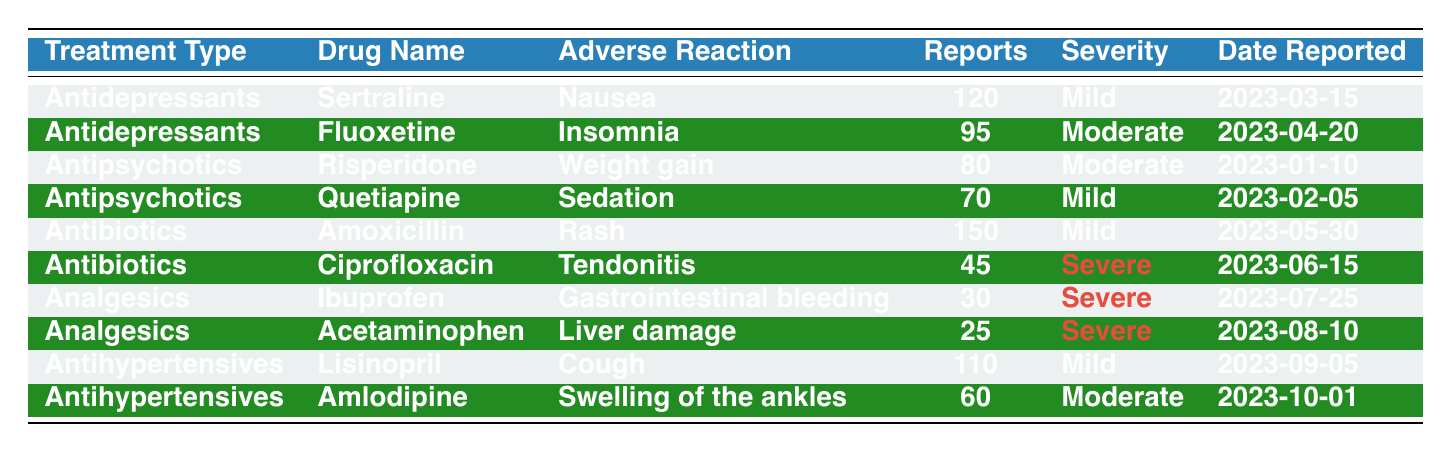What is the drug with the highest number of adverse reaction reports? The table lists the number of reports for each drug. Amoxicillin has the highest number at 150 reports.
Answer: Amoxicillin Which treatment type had the most reports of severe adverse reactions? From the table, Analgesics showed severe reactions with 3 cases (Ibuprofen, Acetaminophen, and Ciprofloxacin). However, only Ciprofloxacin, Ibuprofen, and Acetaminophen reported severe severity, so the treatment type with the highest count of severe reports is Analgesics.
Answer: Analgesics How many adverse reactions were reported for antidepressants? In the table, add the number of reports for both antidepressant drugs: 120 (Sertraline) + 95 (Fluoxetine) = 215 reports total.
Answer: 215 True or False: There were more adverse reaction reports for antibiotics than antihypertensives. Amoxicillin (150) + Ciprofloxacin (45) = 195 for antibiotics and Lisinopril (110) + Amlodipine (60) = 170 for antihypertensives, so it is true that antibiotics had more reports.
Answer: True What is the ratio of severe to mild adverse reactions reported for analgesics? There are 3 severe reactions (from Ibuprofen and Acetaminophen) and 2 mild reactions (total from the table). Hence, the ratio is 3 severe to 2 mild, which simplifies to 3:2.
Answer: 3:2 What was the most common adverse reaction among antihypertensives, and how many reports did it receive? The most common adverse reaction for antihypertensives is a cough from Lisinopril, with 110 reports according to the table.
Answer: Cough, 110 Which drug had the lowest number of adverse reports overall? Looking through the table, Acetaminophen had the lowest number of reports with 25 total.
Answer: Acetaminophen How many total adverse reports are listed for the treatment type Antipsychotics? Adding the numbers for Antipsychotics, Risperidone (80) + Quetiapine (70) gives 150 total reports for this treatment type.
Answer: 150 Which drug reported an adverse reaction on July 25, 2023? Referring to the date, Ibuprofen is listed in the table with a report date of July 25, 2023.
Answer: Ibuprofen Which treatment type had the least amount of adverse reactions reported? Analgesics had the least amount of reports with a total of 55 (Ibuprofen + Acetaminophen) which is less than all others.
Answer: Analgesics What percentage of all adverse reports were attributed to antidepressants? Total reports in the table sum to 705. Antidepressants had 215 reports. Therefore, (215/705) * 100 = ~30.4%.
Answer: ~30.4% 